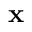<formula> <loc_0><loc_0><loc_500><loc_500>x</formula> 